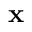<formula> <loc_0><loc_0><loc_500><loc_500>x</formula> 